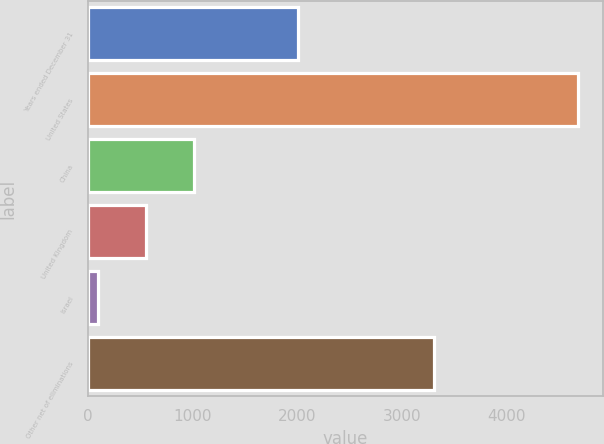<chart> <loc_0><loc_0><loc_500><loc_500><bar_chart><fcel>Years ended December 31<fcel>United States<fcel>China<fcel>United Kingdom<fcel>Israel<fcel>Other net of eliminations<nl><fcel>2013<fcel>4683<fcel>1016.6<fcel>558.3<fcel>100<fcel>3305<nl></chart> 